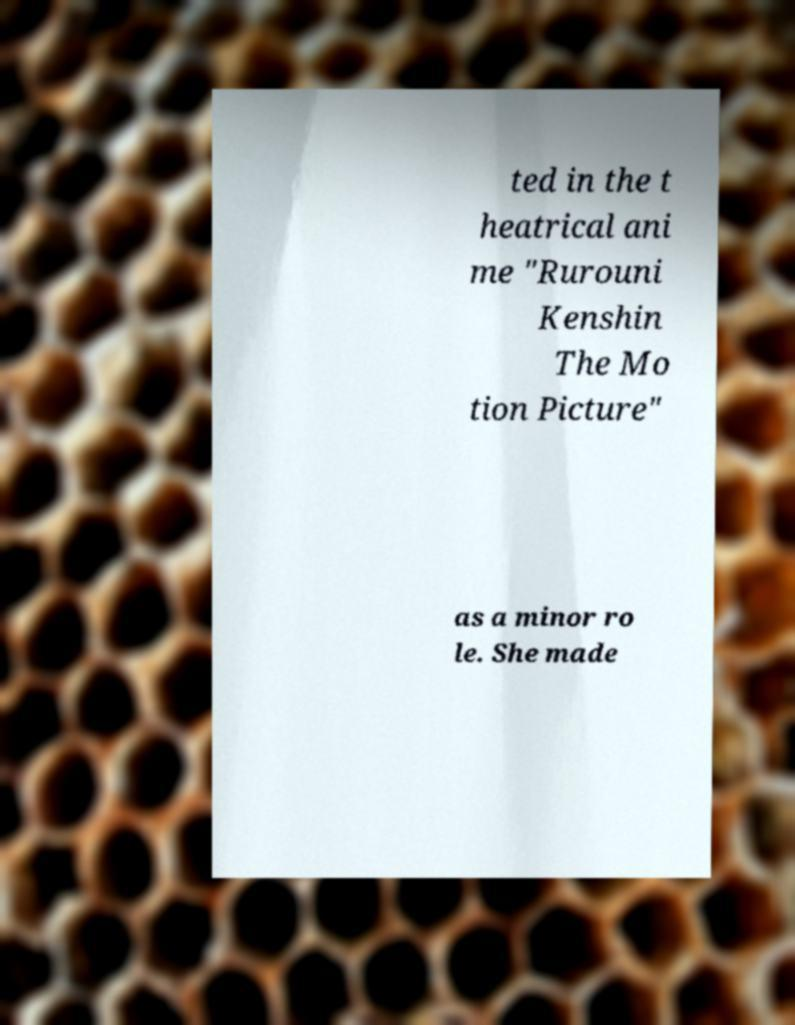Please identify and transcribe the text found in this image. ted in the t heatrical ani me "Rurouni Kenshin The Mo tion Picture" as a minor ro le. She made 